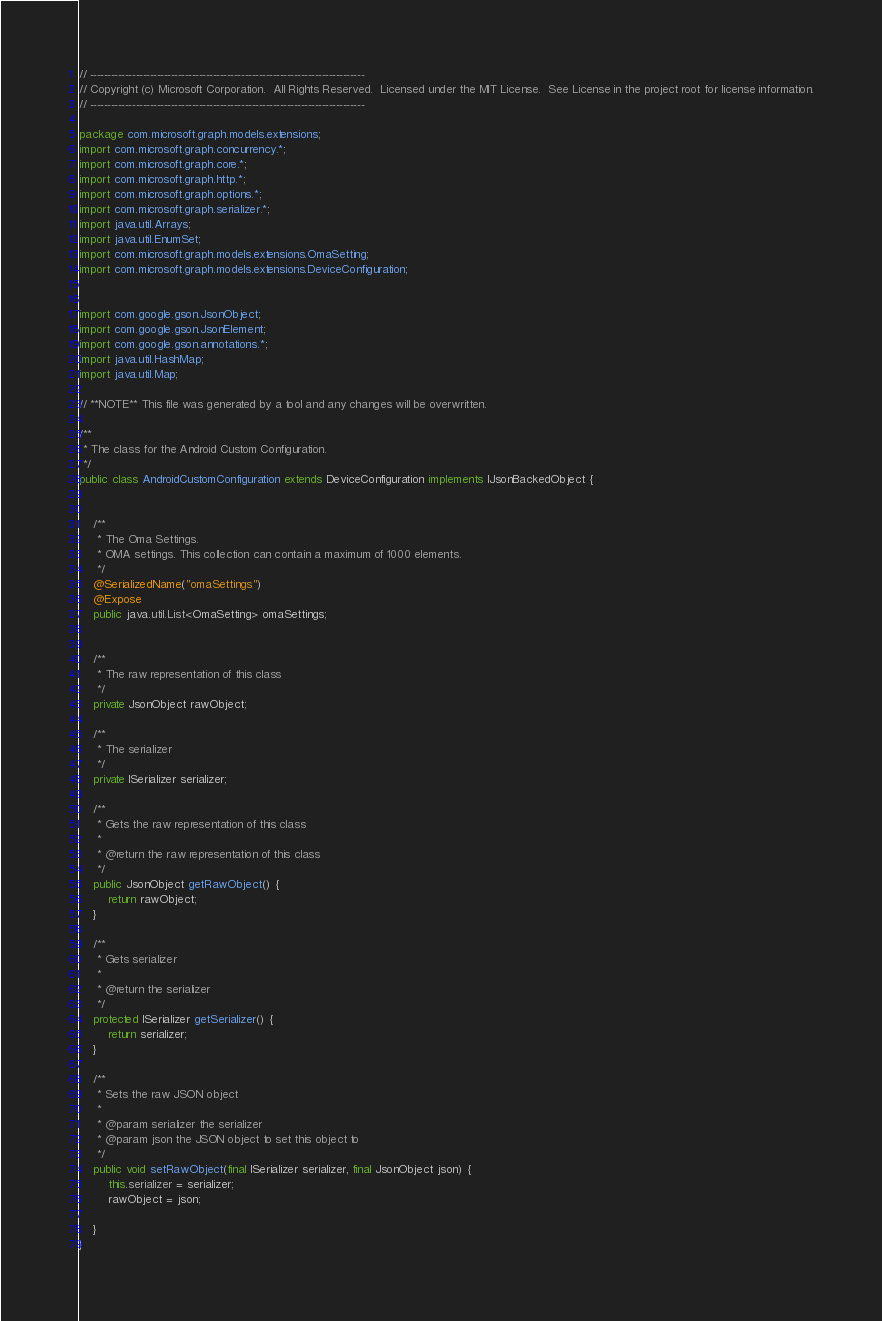Convert code to text. <code><loc_0><loc_0><loc_500><loc_500><_Java_>// ------------------------------------------------------------------------------
// Copyright (c) Microsoft Corporation.  All Rights Reserved.  Licensed under the MIT License.  See License in the project root for license information.
// ------------------------------------------------------------------------------

package com.microsoft.graph.models.extensions;
import com.microsoft.graph.concurrency.*;
import com.microsoft.graph.core.*;
import com.microsoft.graph.http.*;
import com.microsoft.graph.options.*;
import com.microsoft.graph.serializer.*;
import java.util.Arrays;
import java.util.EnumSet;
import com.microsoft.graph.models.extensions.OmaSetting;
import com.microsoft.graph.models.extensions.DeviceConfiguration;


import com.google.gson.JsonObject;
import com.google.gson.JsonElement;
import com.google.gson.annotations.*;
import java.util.HashMap;
import java.util.Map;

// **NOTE** This file was generated by a tool and any changes will be overwritten.

/**
 * The class for the Android Custom Configuration.
 */
public class AndroidCustomConfiguration extends DeviceConfiguration implements IJsonBackedObject {


    /**
     * The Oma Settings.
     * OMA settings. This collection can contain a maximum of 1000 elements.
     */
    @SerializedName("omaSettings")
    @Expose
    public java.util.List<OmaSetting> omaSettings;


    /**
     * The raw representation of this class
     */
    private JsonObject rawObject;

    /**
     * The serializer
     */
    private ISerializer serializer;

    /**
     * Gets the raw representation of this class
     *
     * @return the raw representation of this class
     */
    public JsonObject getRawObject() {
        return rawObject;
    }

    /**
     * Gets serializer
     *
     * @return the serializer
     */
    protected ISerializer getSerializer() {
        return serializer;
    }

    /**
     * Sets the raw JSON object
     *
     * @param serializer the serializer
     * @param json the JSON object to set this object to
     */
    public void setRawObject(final ISerializer serializer, final JsonObject json) {
        this.serializer = serializer;
        rawObject = json;

    }
}
</code> 